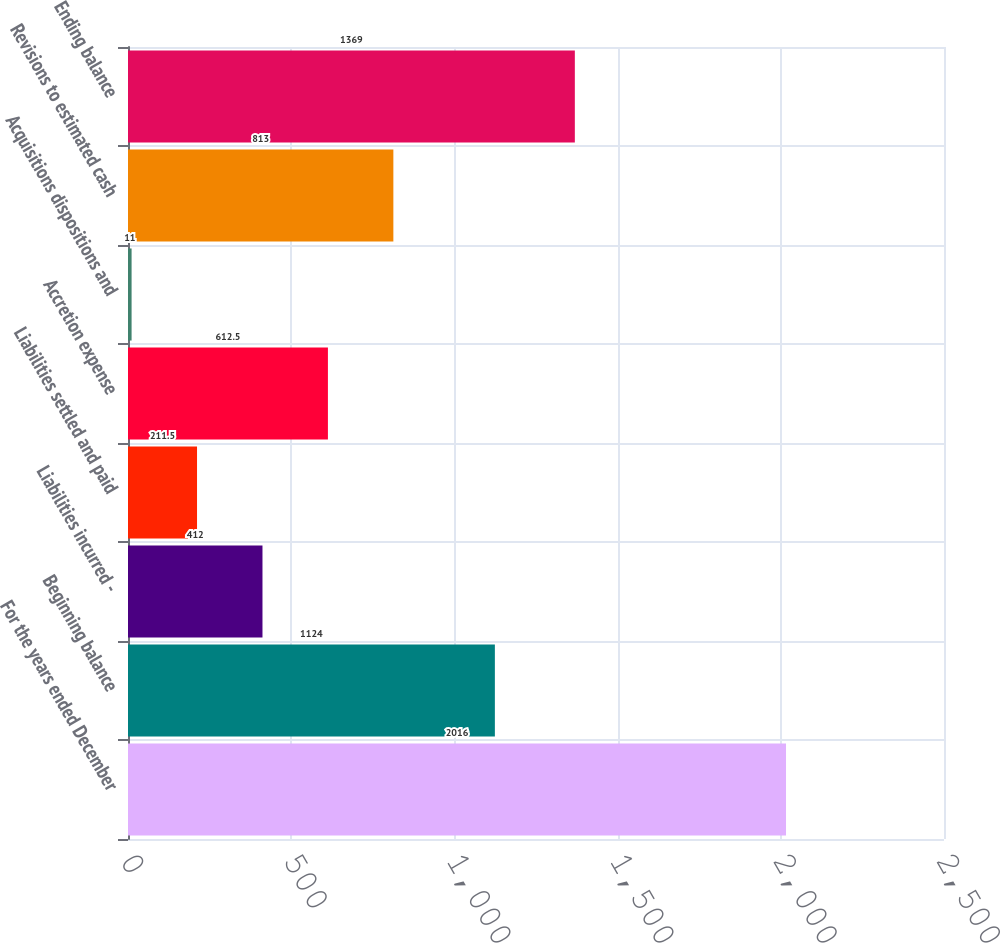<chart> <loc_0><loc_0><loc_500><loc_500><bar_chart><fcel>For the years ended December<fcel>Beginning balance<fcel>Liabilities incurred -<fcel>Liabilities settled and paid<fcel>Accretion expense<fcel>Acquisitions dispositions and<fcel>Revisions to estimated cash<fcel>Ending balance<nl><fcel>2016<fcel>1124<fcel>412<fcel>211.5<fcel>612.5<fcel>11<fcel>813<fcel>1369<nl></chart> 